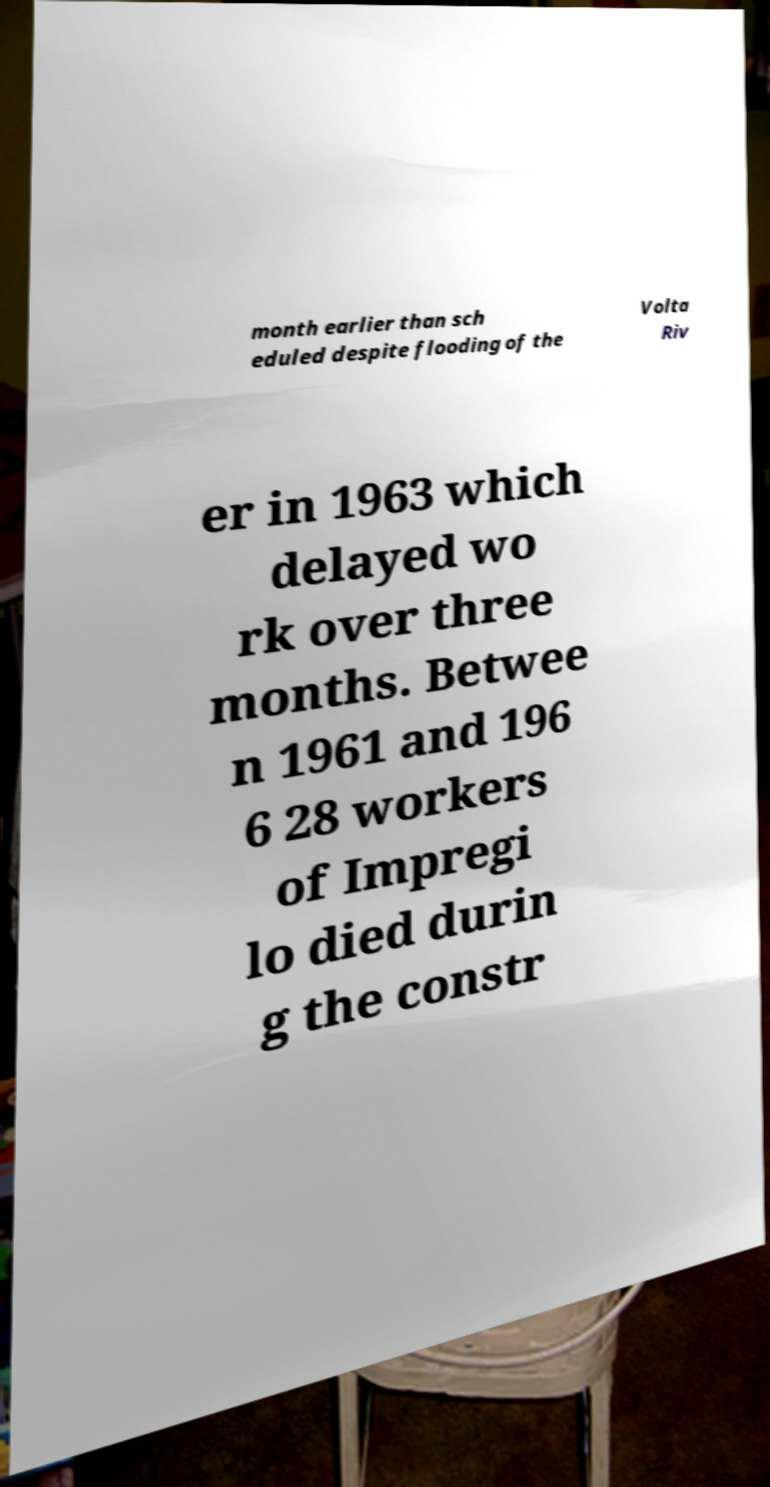Can you read and provide the text displayed in the image?This photo seems to have some interesting text. Can you extract and type it out for me? month earlier than sch eduled despite flooding of the Volta Riv er in 1963 which delayed wo rk over three months. Betwee n 1961 and 196 6 28 workers of Impregi lo died durin g the constr 